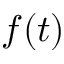<formula> <loc_0><loc_0><loc_500><loc_500>f ( t )</formula> 